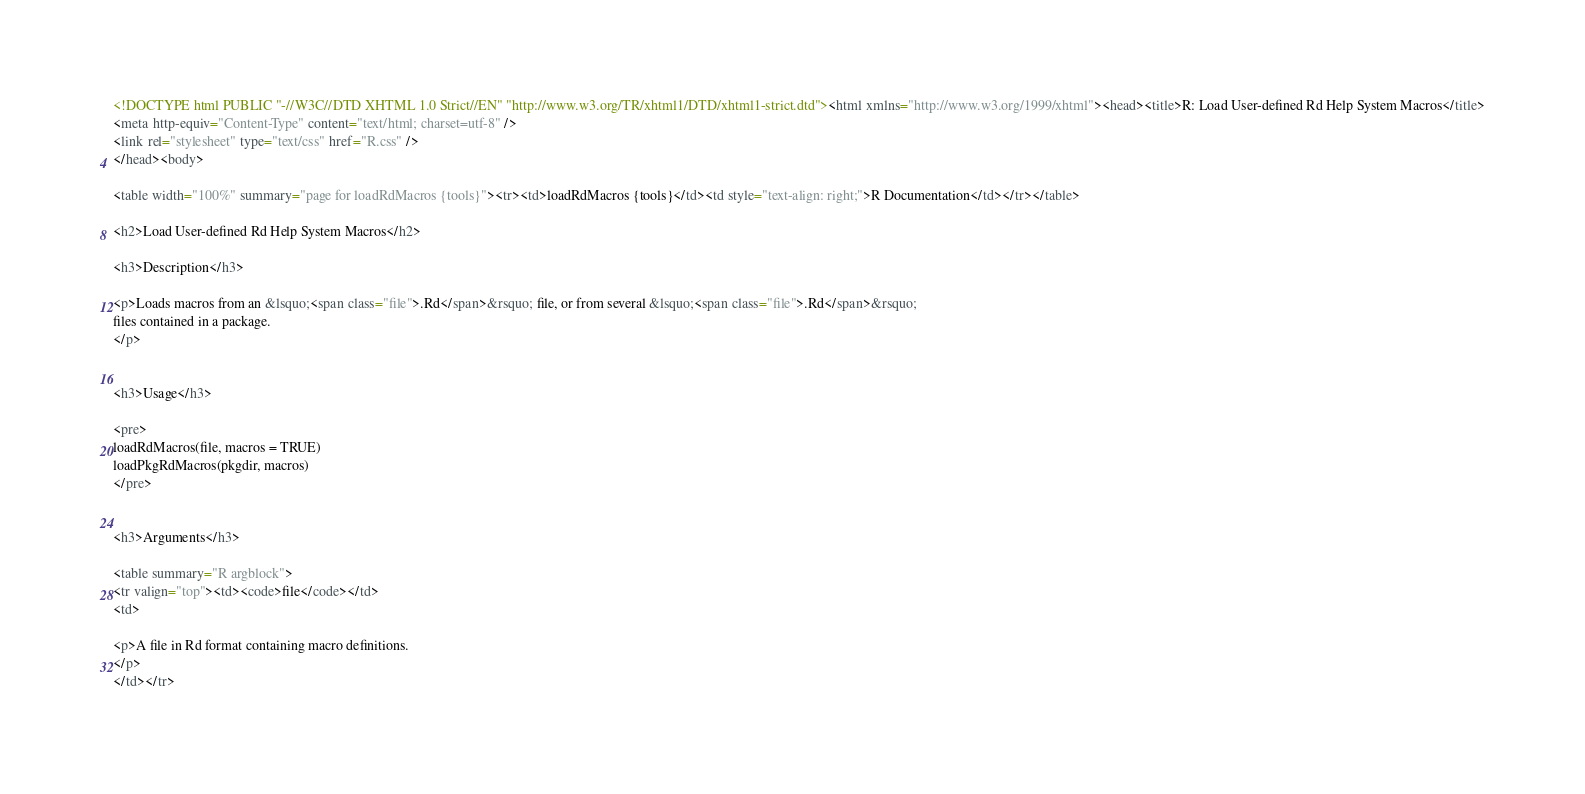Convert code to text. <code><loc_0><loc_0><loc_500><loc_500><_HTML_><!DOCTYPE html PUBLIC "-//W3C//DTD XHTML 1.0 Strict//EN" "http://www.w3.org/TR/xhtml1/DTD/xhtml1-strict.dtd"><html xmlns="http://www.w3.org/1999/xhtml"><head><title>R: Load User-defined Rd Help System Macros</title>
<meta http-equiv="Content-Type" content="text/html; charset=utf-8" />
<link rel="stylesheet" type="text/css" href="R.css" />
</head><body>

<table width="100%" summary="page for loadRdMacros {tools}"><tr><td>loadRdMacros {tools}</td><td style="text-align: right;">R Documentation</td></tr></table>

<h2>Load User-defined Rd Help System Macros</h2>

<h3>Description</h3>

<p>Loads macros from an &lsquo;<span class="file">.Rd</span>&rsquo; file, or from several &lsquo;<span class="file">.Rd</span>&rsquo;
files contained in a package.
</p>


<h3>Usage</h3>

<pre>
loadRdMacros(file, macros = TRUE)
loadPkgRdMacros(pkgdir, macros)
</pre>


<h3>Arguments</h3>

<table summary="R argblock">
<tr valign="top"><td><code>file</code></td>
<td>

<p>A file in Rd format containing macro definitions.
</p>
</td></tr></code> 